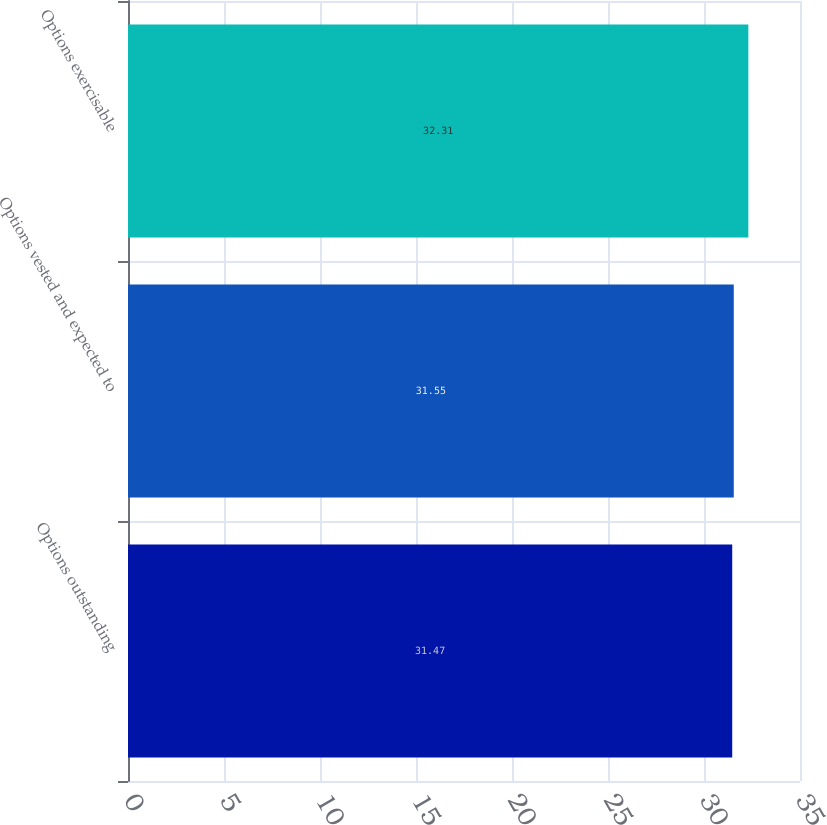Convert chart. <chart><loc_0><loc_0><loc_500><loc_500><bar_chart><fcel>Options outstanding<fcel>Options vested and expected to<fcel>Options exercisable<nl><fcel>31.47<fcel>31.55<fcel>32.31<nl></chart> 